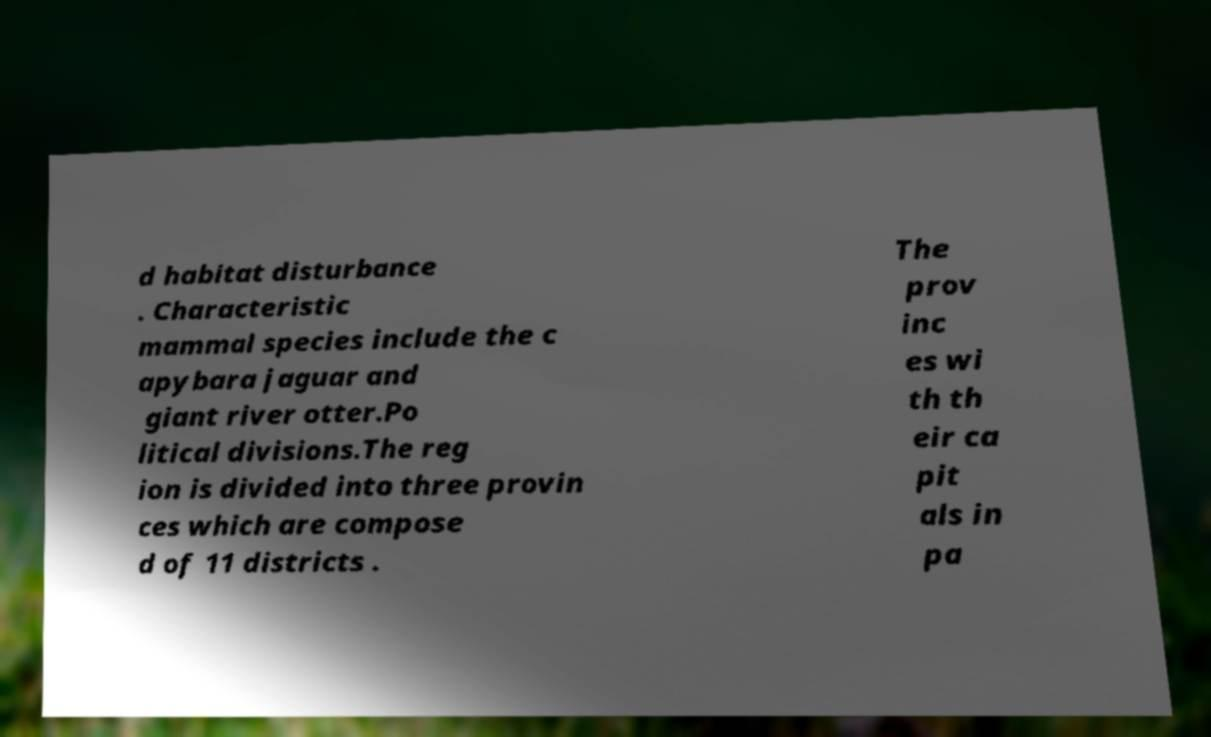I need the written content from this picture converted into text. Can you do that? d habitat disturbance . Characteristic mammal species include the c apybara jaguar and giant river otter.Po litical divisions.The reg ion is divided into three provin ces which are compose d of 11 districts . The prov inc es wi th th eir ca pit als in pa 